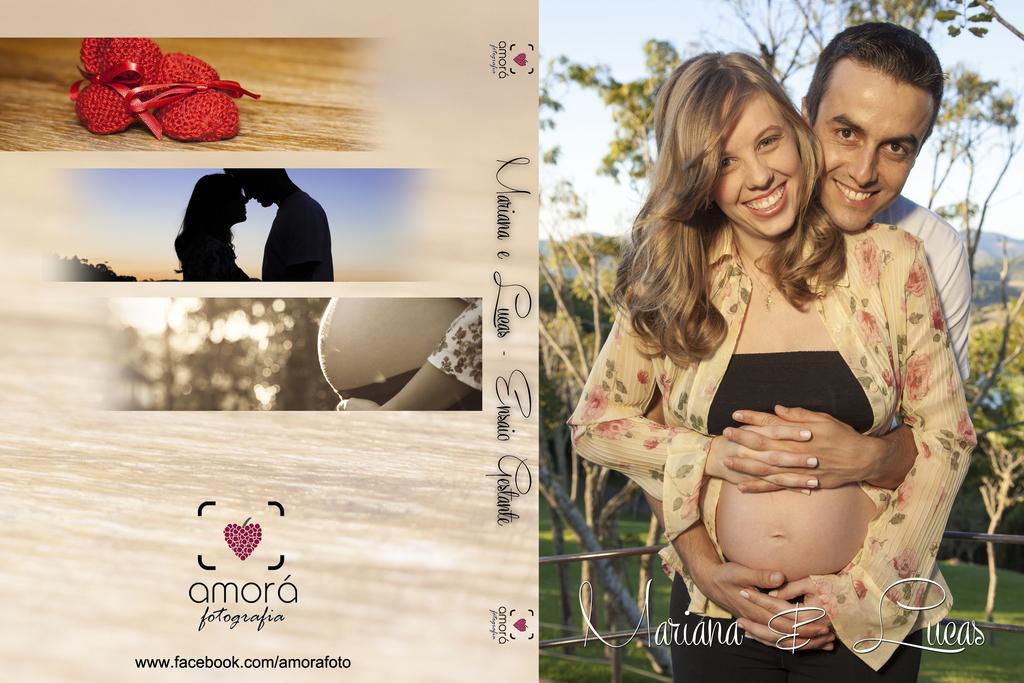In one or two sentences, can you explain what this image depicts? This is an edited image, in this image on the right side there are two persons who are standing and smiling and in the background there are trees. On the left side there are two persons and some other objects and also there is some text. 